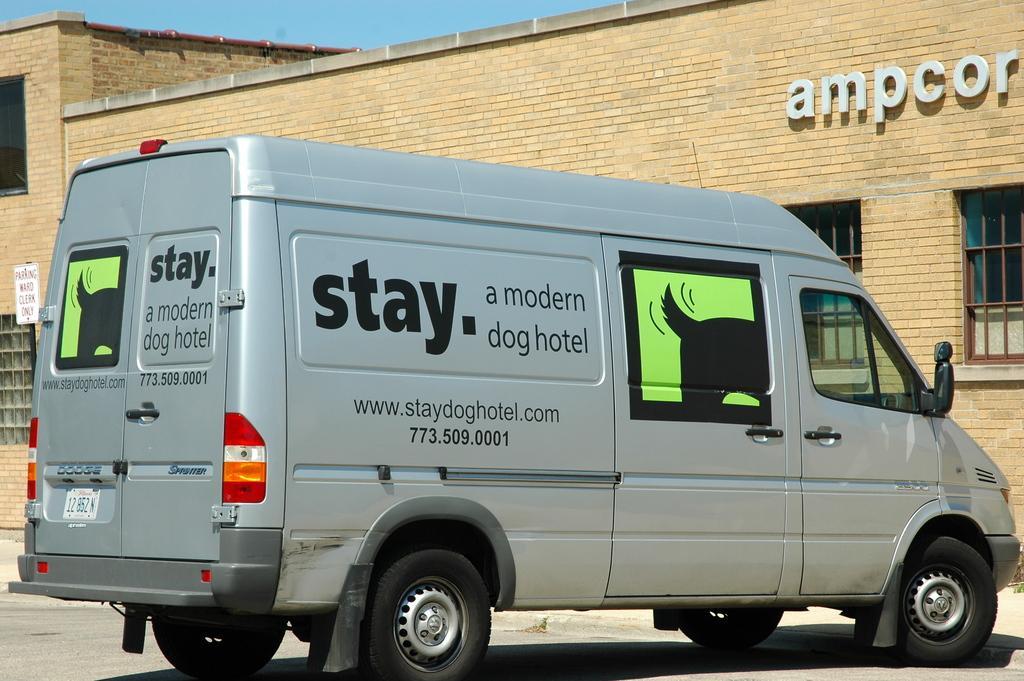Describe this image in one or two sentences. In this picture we can observe a vehicle which is in silver color. In the background there is a cream color building and a sky. 